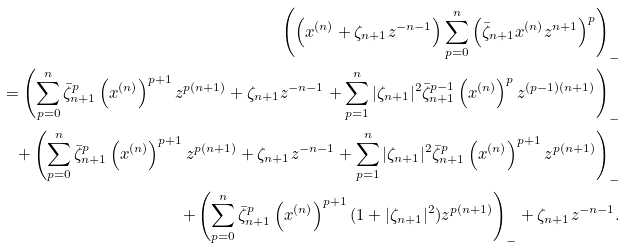Convert formula to latex. <formula><loc_0><loc_0><loc_500><loc_500>\left ( \left ( x ^ { ( n ) } + \zeta _ { n + 1 } z ^ { - n - 1 } \right ) \sum _ { p = 0 } ^ { n } \left ( \bar { \zeta } _ { n + 1 } x ^ { ( n ) } z ^ { n + 1 } \right ) ^ { p } \right ) _ { - } \\ = \left ( \sum _ { p = 0 } ^ { n } \bar { \zeta } _ { n + 1 } ^ { p } \left ( x ^ { ( n ) } \right ) ^ { p + 1 } z ^ { p ( n + 1 ) } + \zeta _ { n + 1 } z ^ { - n - 1 } + \sum _ { p = 1 } ^ { n } | \zeta _ { n + 1 } | ^ { 2 } \bar { \zeta } _ { n + 1 } ^ { p - 1 } \left ( x ^ { ( n ) } \right ) ^ { p } z ^ { ( p - 1 ) ( n + 1 ) } \right ) _ { - } \\ \quad + \left ( \sum _ { p = 0 } ^ { n } \bar { \zeta } _ { n + 1 } ^ { p } \left ( x ^ { ( n ) } \right ) ^ { p + 1 } z ^ { p ( n + 1 ) } + \zeta _ { n + 1 } z ^ { - n - 1 } + \sum _ { p = 1 } ^ { n } | \zeta _ { n + 1 } | ^ { 2 } \bar { \zeta } _ { n + 1 } ^ { p } \left ( x ^ { ( n ) } \right ) ^ { p + 1 } z ^ { p ( n + 1 ) } \right ) _ { - } \\ \quad + \left ( \sum _ { p = 0 } ^ { n } \bar { \zeta } _ { n + 1 } ^ { p } \left ( x ^ { ( n ) } \right ) ^ { p + 1 } ( 1 + | \zeta _ { n + 1 } | ^ { 2 } ) z ^ { p ( n + 1 ) } \right ) _ { - } + \zeta _ { n + 1 } z ^ { - n - 1 } .</formula> 